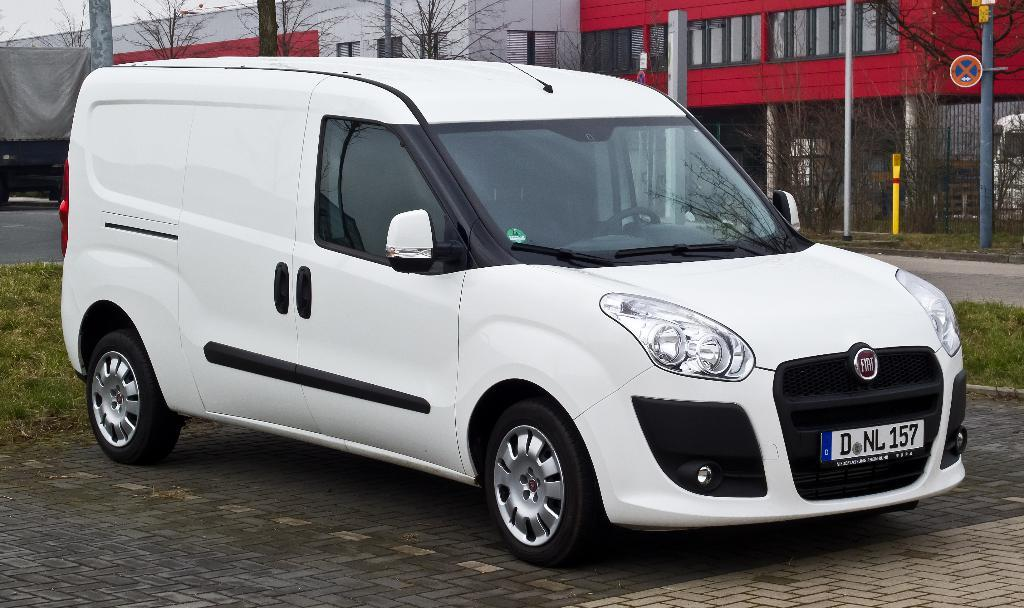What is located on the ground in the image? There is a vehicle on the ground in the image. What can be seen in the distance behind the vehicle? There is a building and trees in the background of the image. Are there any other structures visible in the background? Yes, there are poles in the background of the image. What type of shoe is being used to exercise the muscles of the tooth in the image? There is no shoe, exercise, or tooth present in the image. 